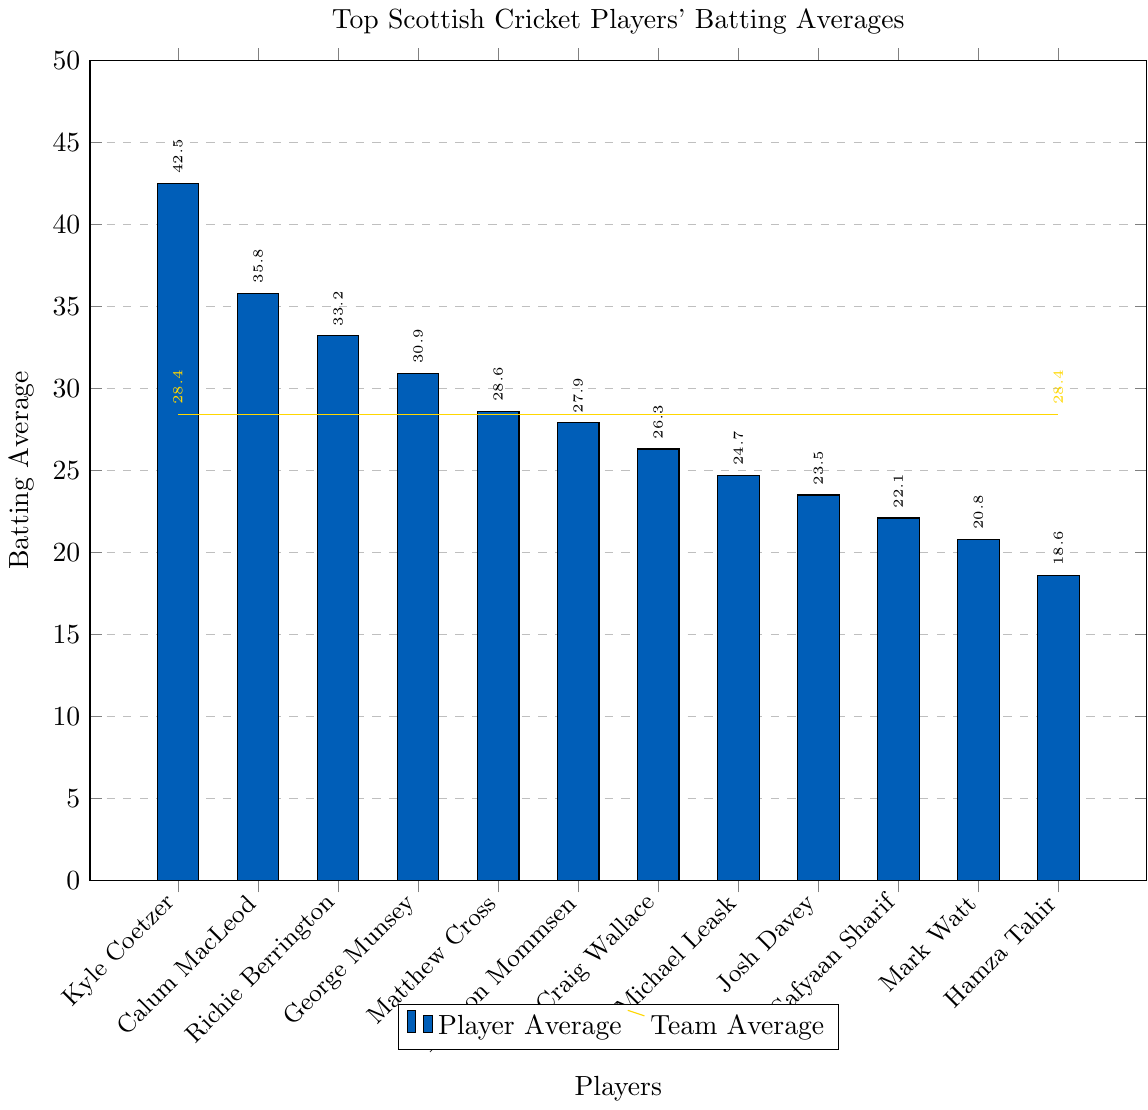What's the highest batting average among the players? The highest batting average can be found by looking for the tallest bar in the chart. The tallest bar corresponds to Kyle Coetzer with a batting average of 42.5.
Answer: 42.5 How many players have a higher batting average than the team average? Identify the team average line (28.4) and count the number of bars taller than this line. These players are Kyle Coetzer (42.5), Calum MacLeod (35.8), Richie Berrington (33.2), George Munsey (30.9), and Matthew Cross (28.6).
Answer: 5 Which player's batting average is closest to the team average? Find the bar with a value closest to the team average (28.4). This is Matthew Cross with a batting average of 28.6.
Answer: Matthew Cross What is the difference between the highest and lowest batting averages? The highest average is 42.5 (Kyle Coetzer), and the lowest is 18.6 (Hamza Tahir). The difference is 42.5 - 18.6 = 23.9.
Answer: 23.9 Name all the players with a batting average below 25. Look for bars that are below the 25 mark. These players are Michael Leask (24.7), Josh Davey (23.5), Safyaan Sharif (22.1), Mark Watt (20.8), and Hamza Tahir (18.6).
Answer: Michael Leask, Josh Davey, Safyaan Sharif, Mark Watt, Hamza Tahir Which players have a batting average between 30 and 35? Identify the bars that fall between the 30 and 35 range. These players are George Munsey (30.9) and Richie Berrington (33.2).
Answer: George Munsey, Richie Berrington How does Kyle Coetzer's batting average compare to the team average? Compare Kyle Coetzer's average (42.5) to the team average (28.4). Kyle Coetzer's average is higher.
Answer: Higher What's the average batting average of the top 3 players? Add the batting averages of the top 3 players Kyle Coetzer (42.5), Calum MacLeod (35.8), and Richie Berrington (33.2), then divide by 3. (42.5 + 35.8 + 33.2)/3 = 37.17.
Answer: 37.17 Which players have a batting average lower than Mark Watt? Identify bars lower than Mark Watt's average (20.8), and no player has a lower batting average than Mark Watt's. So the answer is none.
Answer: None Compare the batting average of George Munsey and Preston Mommsen. Who has a higher batting average? Compare the bars for George Munsey (30.9) and Preston Mommsen (27.9). George Munsey has a higher batting average.
Answer: George Munsey 